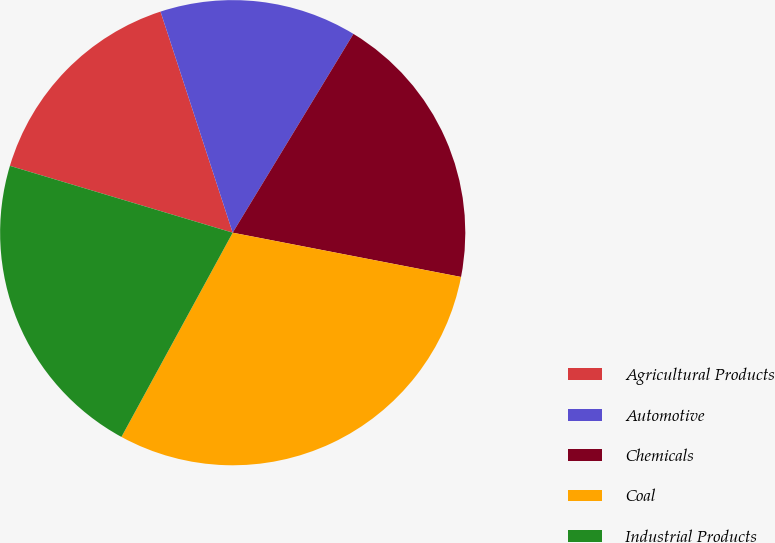<chart> <loc_0><loc_0><loc_500><loc_500><pie_chart><fcel>Agricultural Products<fcel>Automotive<fcel>Chemicals<fcel>Coal<fcel>Industrial Products<nl><fcel>15.34%<fcel>13.71%<fcel>19.36%<fcel>29.89%<fcel>21.7%<nl></chart> 